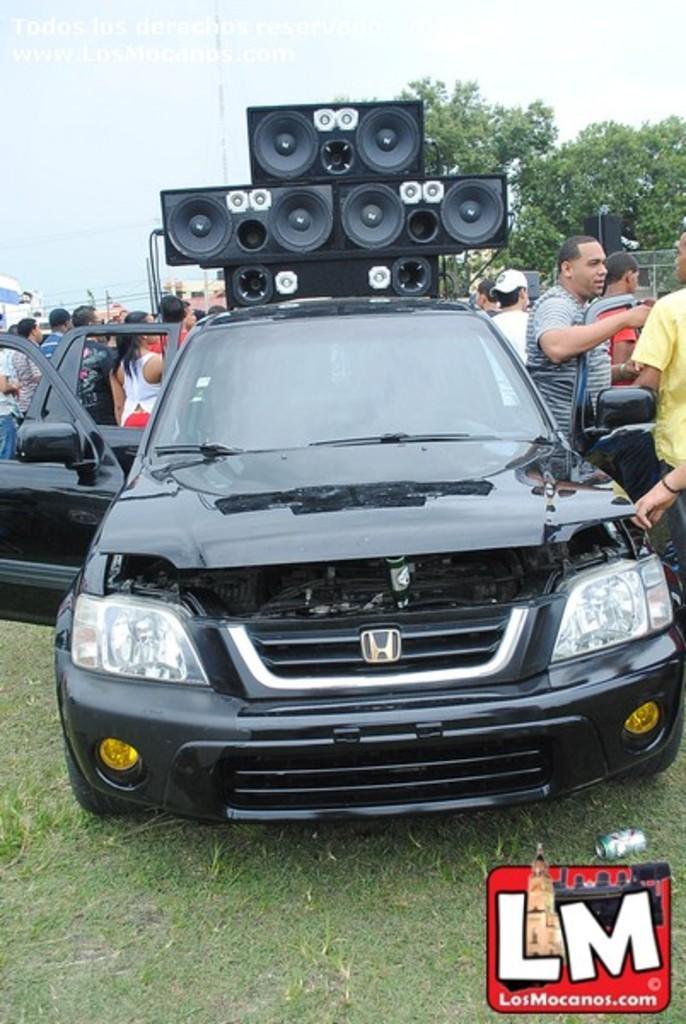Can you describe this image briefly? There is a black color car. On the ground there is grass. In the background there are many people. Also there are speakers near to the car. In the background there are trees and sky. In the right bottom corner there is a watermark. 